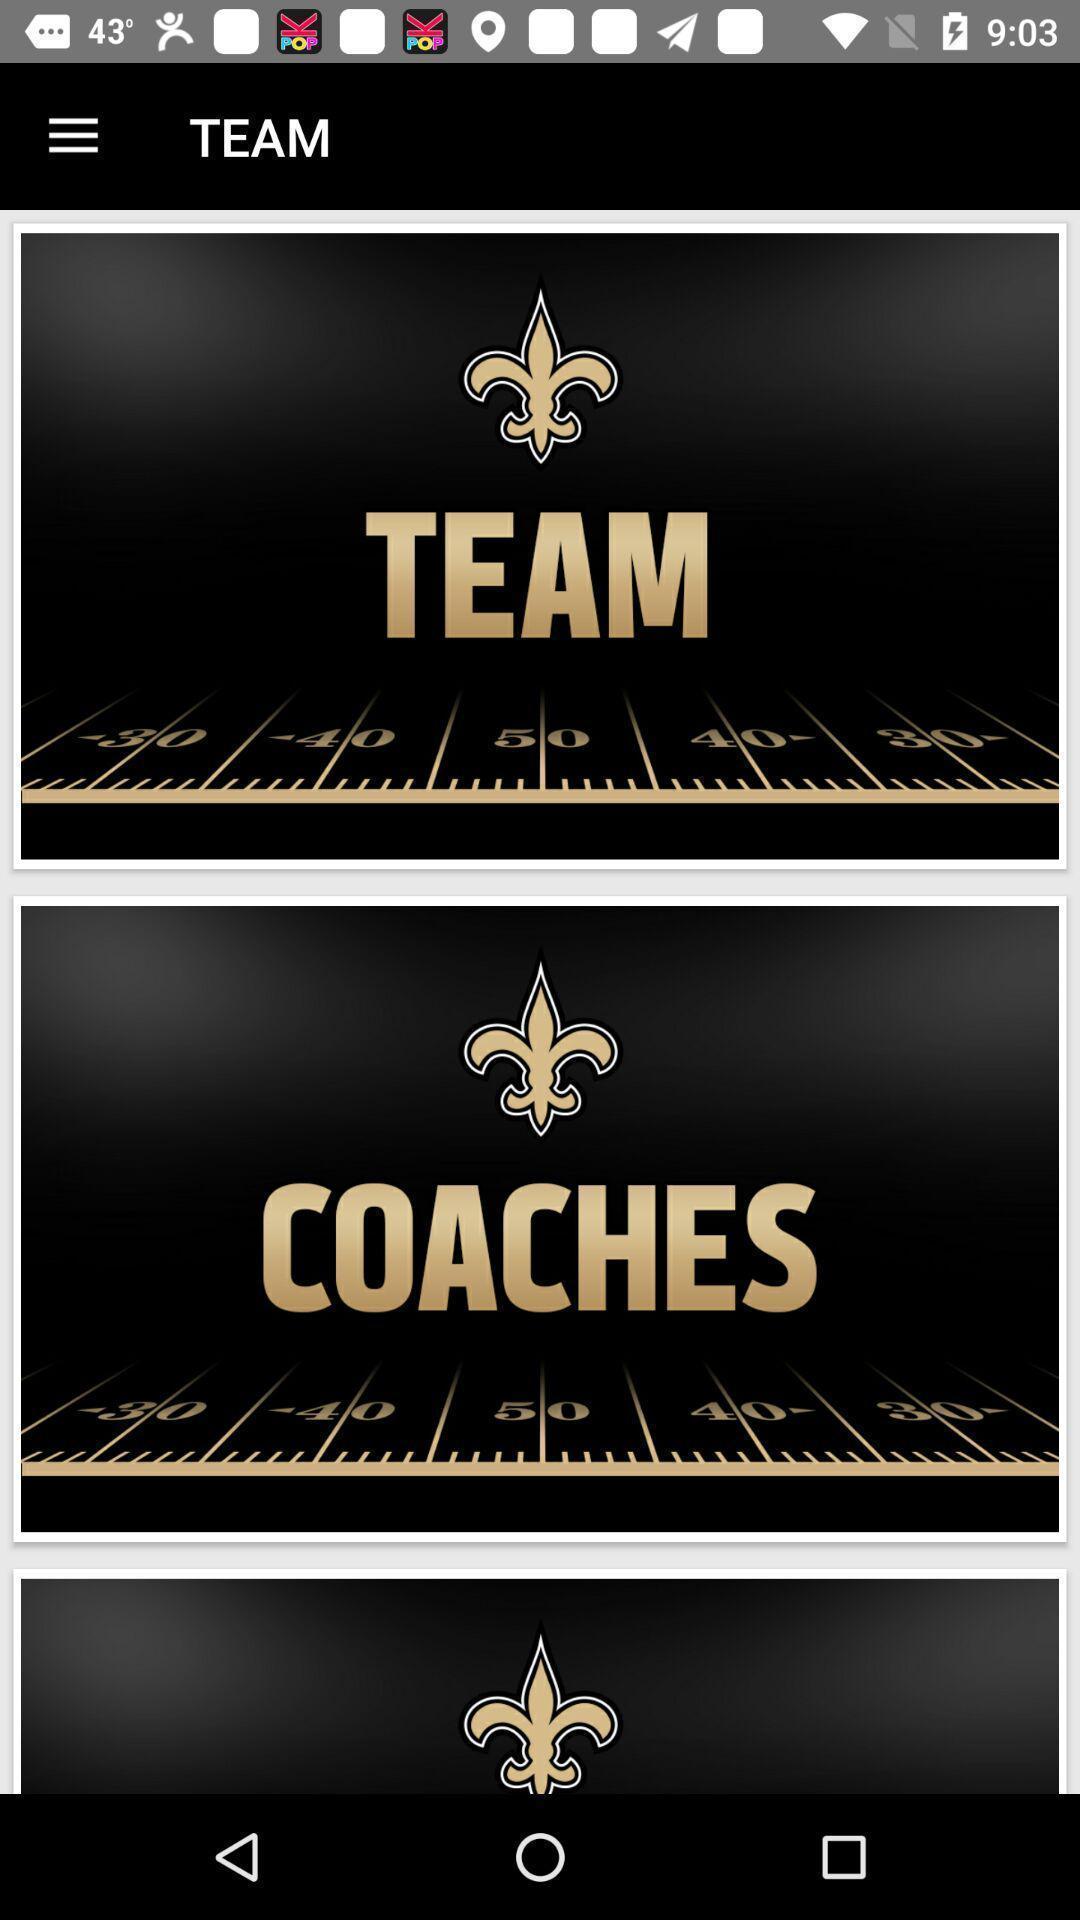Summarize the information in this screenshot. Welcome page. 